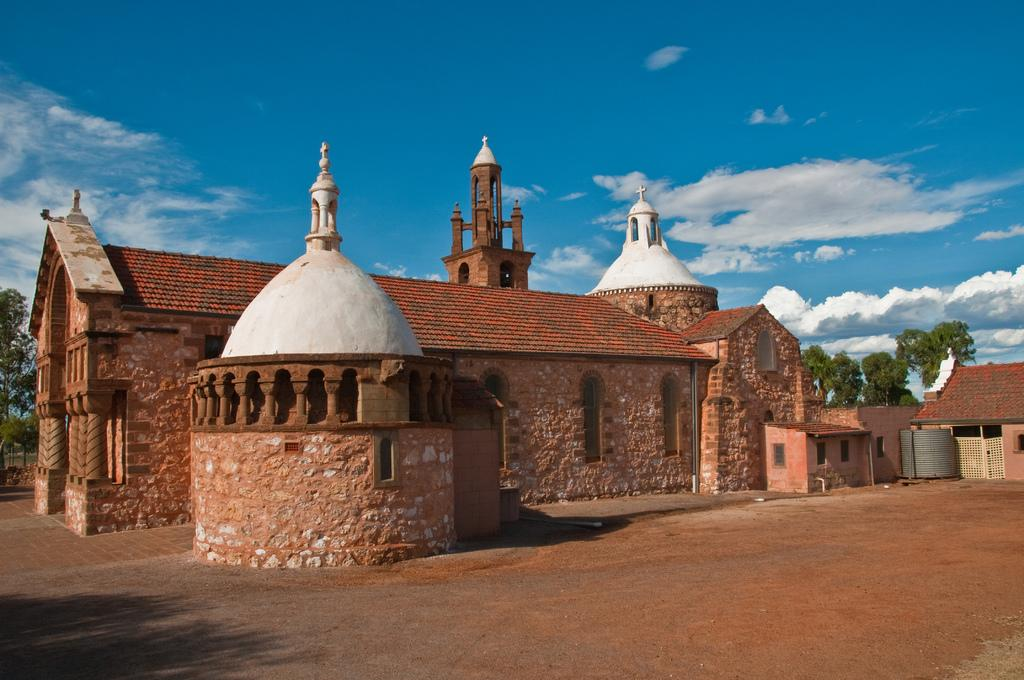What type of structure is in the picture? There is a house in the picture. What can be seen in the background of the picture? There are trees in the background of the picture. What is visible at the top of the picture? The sky is visible at the top of the picture. What type of pollution can be seen in the picture? There is no pollution visible in the picture; it features a house, trees, and the sky. What tool is being used to fix the house in the picture? There is no tool or repair work being depicted in the picture; it simply shows a house, trees, and the sky. 